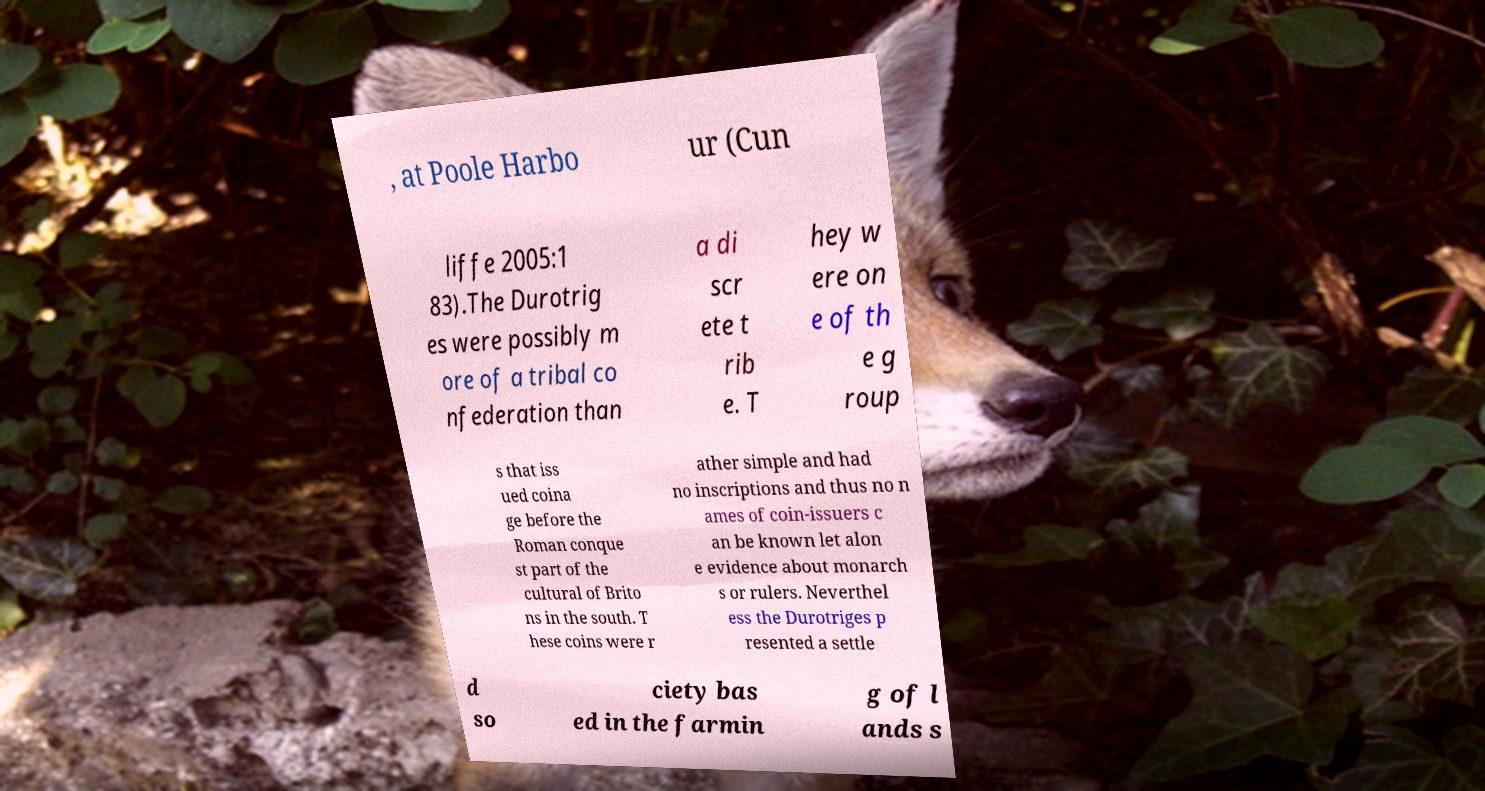Can you read and provide the text displayed in the image?This photo seems to have some interesting text. Can you extract and type it out for me? , at Poole Harbo ur (Cun liffe 2005:1 83).The Durotrig es were possibly m ore of a tribal co nfederation than a di scr ete t rib e. T hey w ere on e of th e g roup s that iss ued coina ge before the Roman conque st part of the cultural of Brito ns in the south. T hese coins were r ather simple and had no inscriptions and thus no n ames of coin-issuers c an be known let alon e evidence about monarch s or rulers. Neverthel ess the Durotriges p resented a settle d so ciety bas ed in the farmin g of l ands s 